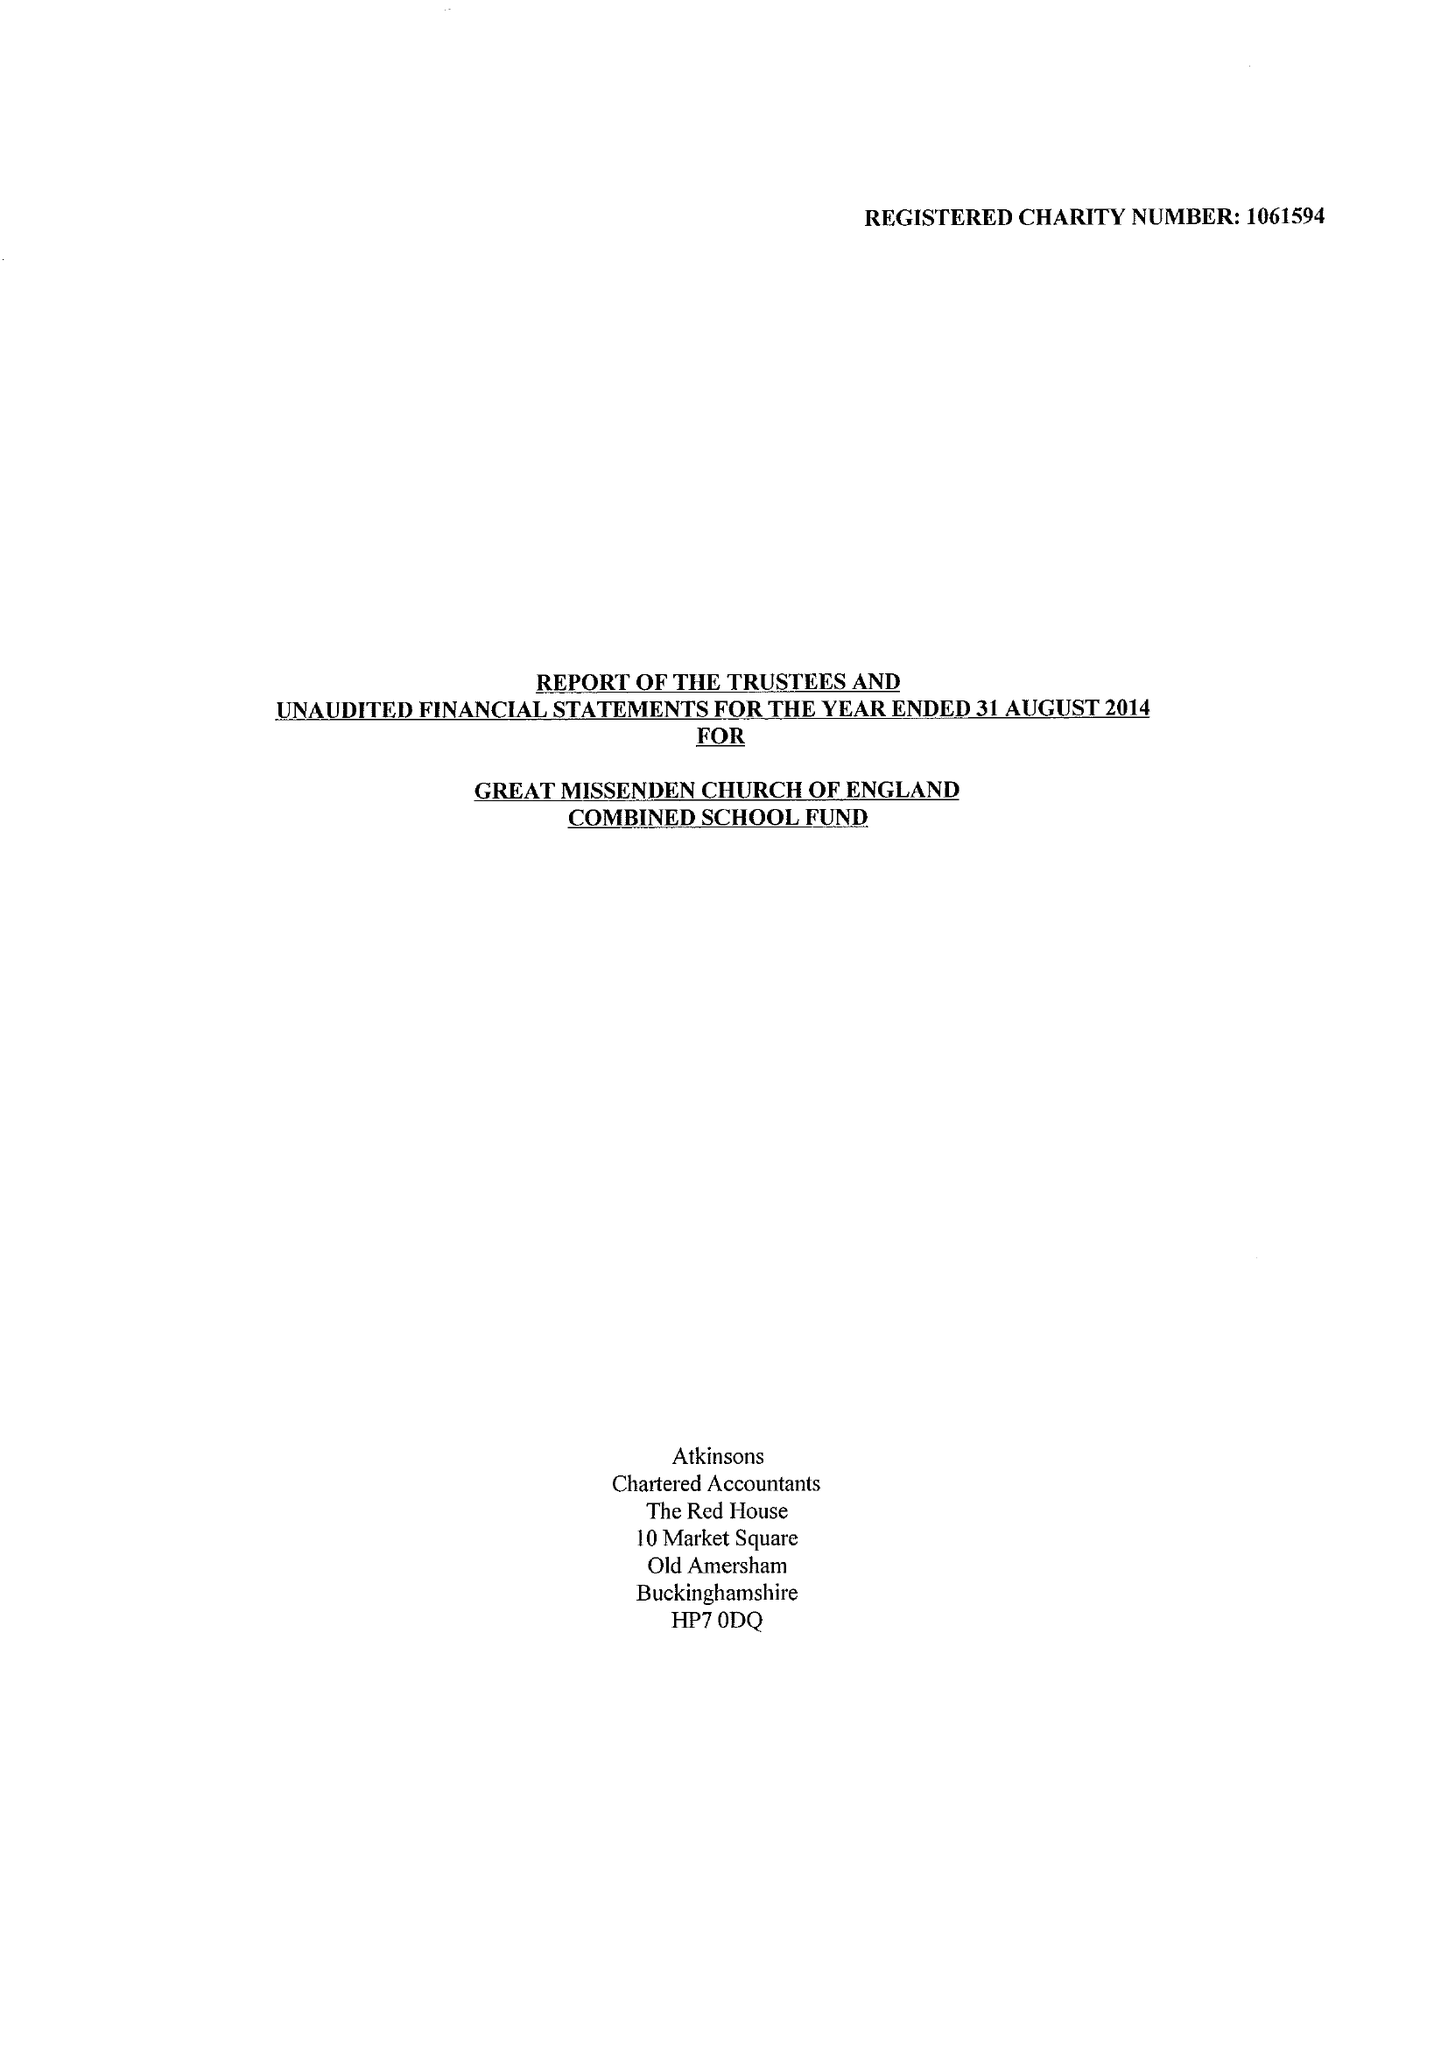What is the value for the address__post_town?
Answer the question using a single word or phrase. GREAT MISSENDEN 